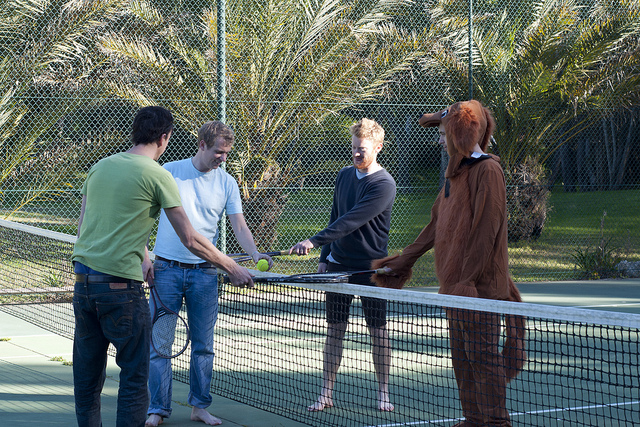Imagine the scene is from a comedy movie. What could happen next? In the next scene of the comedy movie, the person in the dog costume might hilariously trip over their own 'tail' while trying to hit a tennis ball, sending the group into fits of laughter. Suddenly, they notice that a local news crew is filming their antics for an upcoming segment on unconventional ways people celebrate birthdays. As they ham it up for the cameras, one friend decides to prank the 'dog' by stealthily tying his shoe laces together. What ensues is a series of comic misadventures, including a surprise visit from a real dog! 